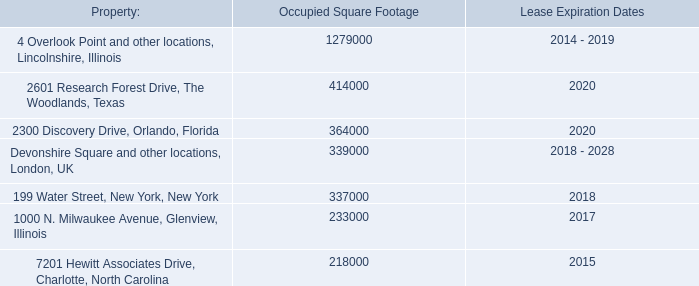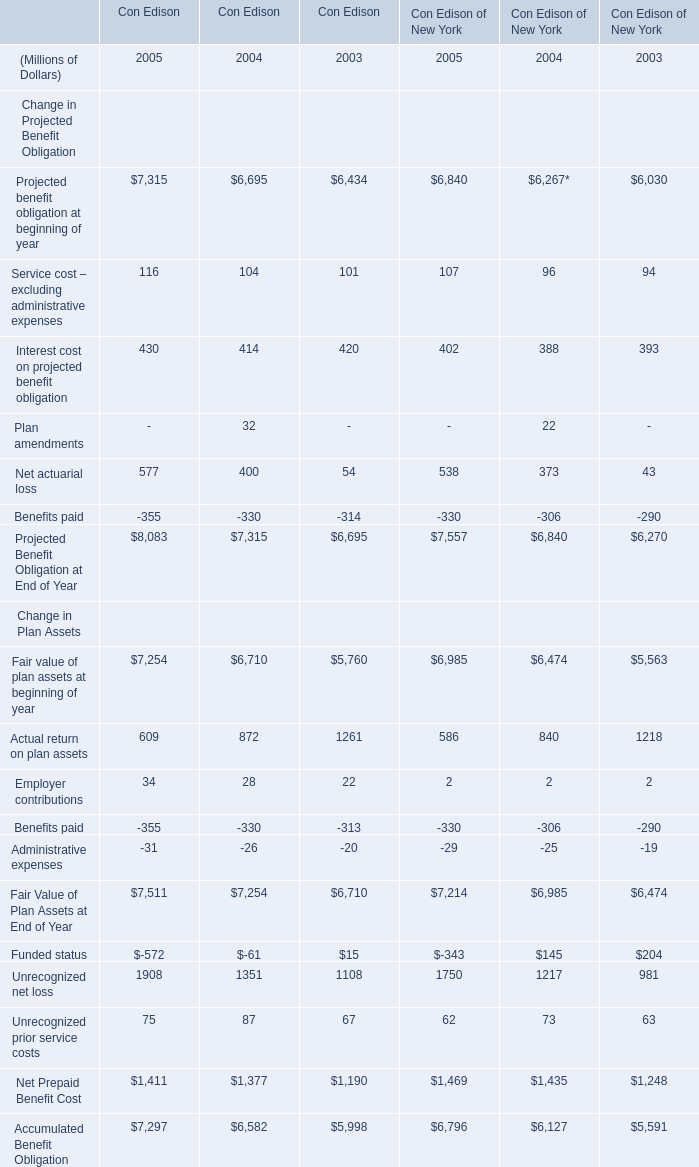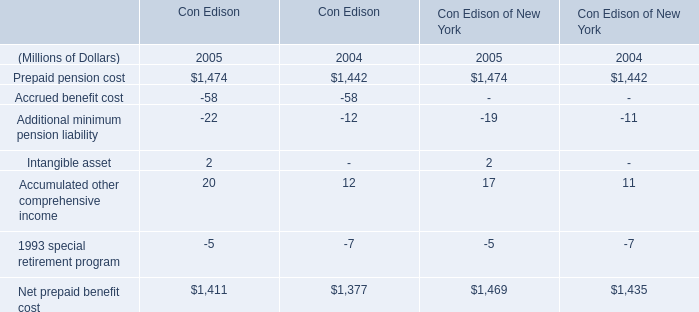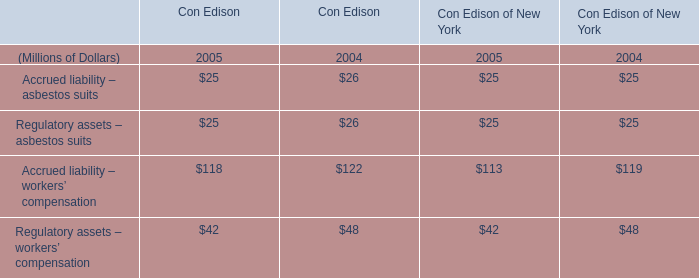What's the sum of Net prepaid benefit cost of Con Edison 2005, and 2300 Discovery Drive, Orlando, Florida of Lease Expiration Dates ? 
Computations: (1411.0 + 2020.0)
Answer: 3431.0. 